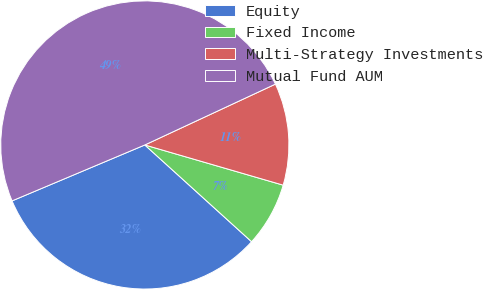Convert chart to OTSL. <chart><loc_0><loc_0><loc_500><loc_500><pie_chart><fcel>Equity<fcel>Fixed Income<fcel>Multi-Strategy Investments<fcel>Mutual Fund AUM<nl><fcel>31.94%<fcel>7.22%<fcel>11.44%<fcel>49.41%<nl></chart> 